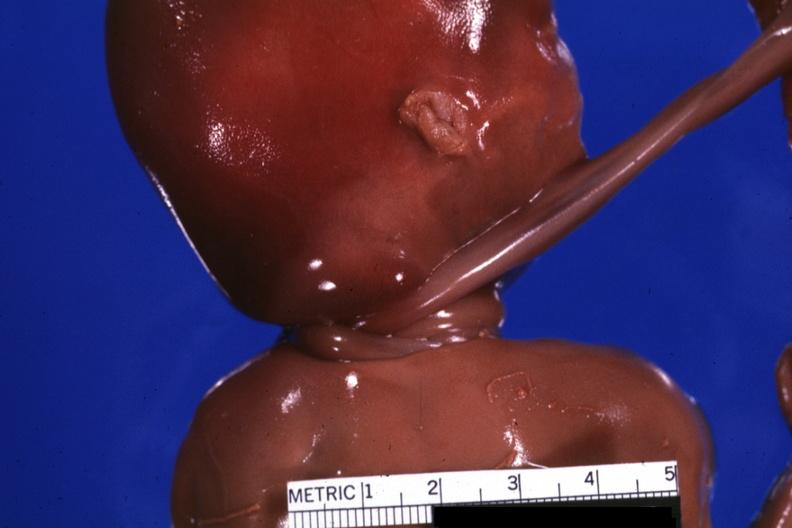what is present?
Answer the question using a single word or phrase. Newborn cord around neck 